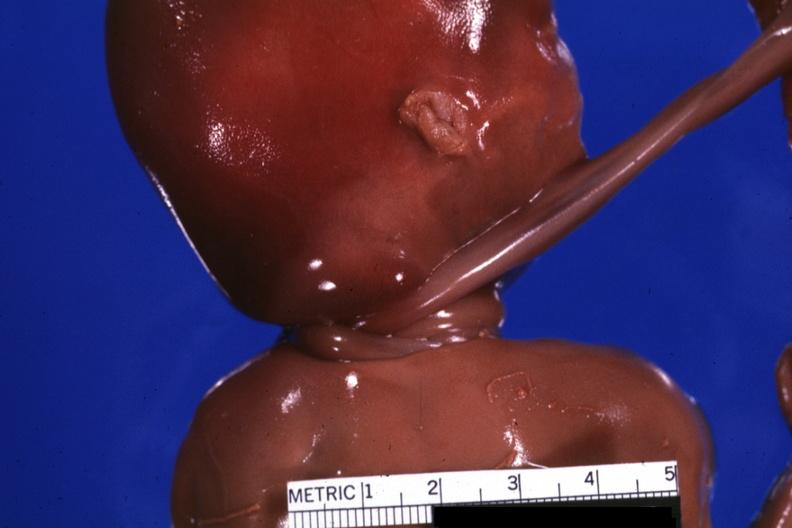what is present?
Answer the question using a single word or phrase. Newborn cord around neck 